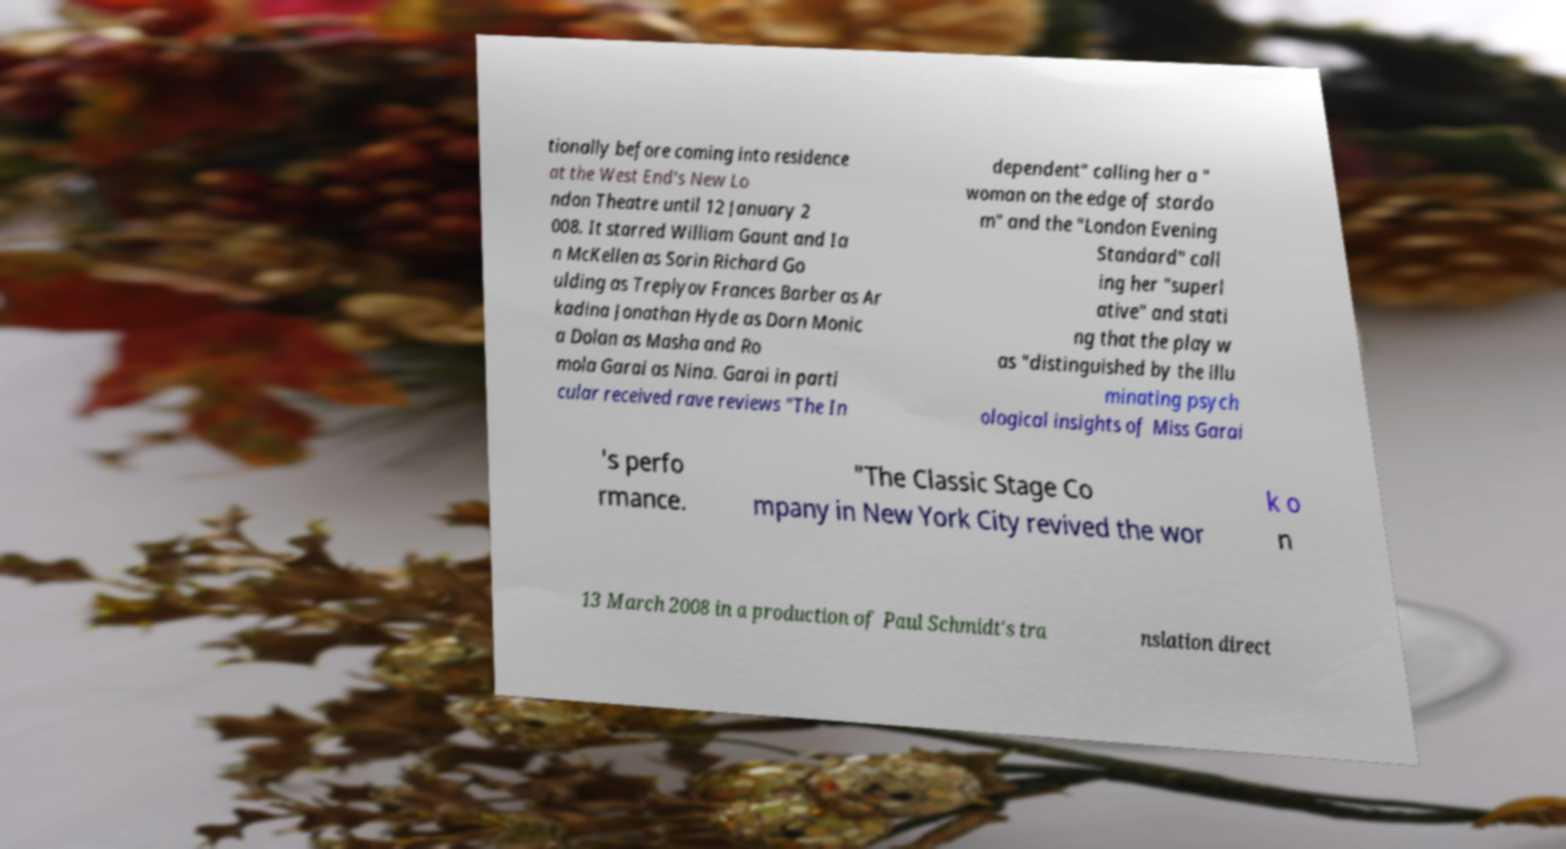There's text embedded in this image that I need extracted. Can you transcribe it verbatim? tionally before coming into residence at the West End's New Lo ndon Theatre until 12 January 2 008. It starred William Gaunt and Ia n McKellen as Sorin Richard Go ulding as Treplyov Frances Barber as Ar kadina Jonathan Hyde as Dorn Monic a Dolan as Masha and Ro mola Garai as Nina. Garai in parti cular received rave reviews "The In dependent" calling her a " woman on the edge of stardo m" and the "London Evening Standard" call ing her "superl ative" and stati ng that the play w as "distinguished by the illu minating psych ological insights of Miss Garai 's perfo rmance. "The Classic Stage Co mpany in New York City revived the wor k o n 13 March 2008 in a production of Paul Schmidt's tra nslation direct 